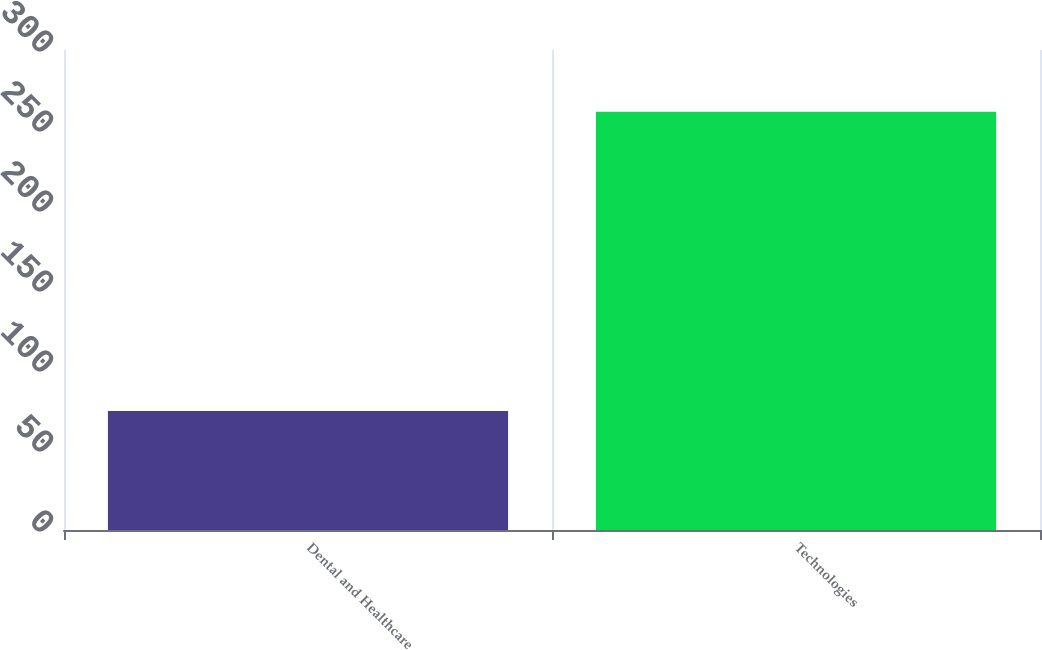Convert chart. <chart><loc_0><loc_0><loc_500><loc_500><bar_chart><fcel>Dental and Healthcare<fcel>Technologies<nl><fcel>74.4<fcel>261.4<nl></chart> 